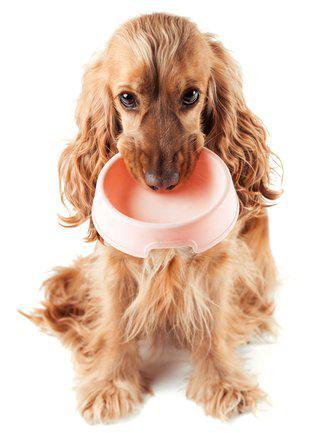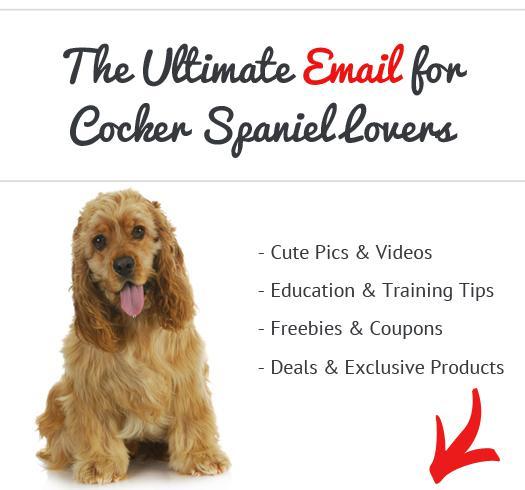The first image is the image on the left, the second image is the image on the right. Examine the images to the left and right. Is the description "An image contains a dog food bowl." accurate? Answer yes or no. Yes. The first image is the image on the left, the second image is the image on the right. For the images displayed, is the sentence "An image includes one golden cocker spaniel with its mouth on an orangish food bowl." factually correct? Answer yes or no. Yes. 